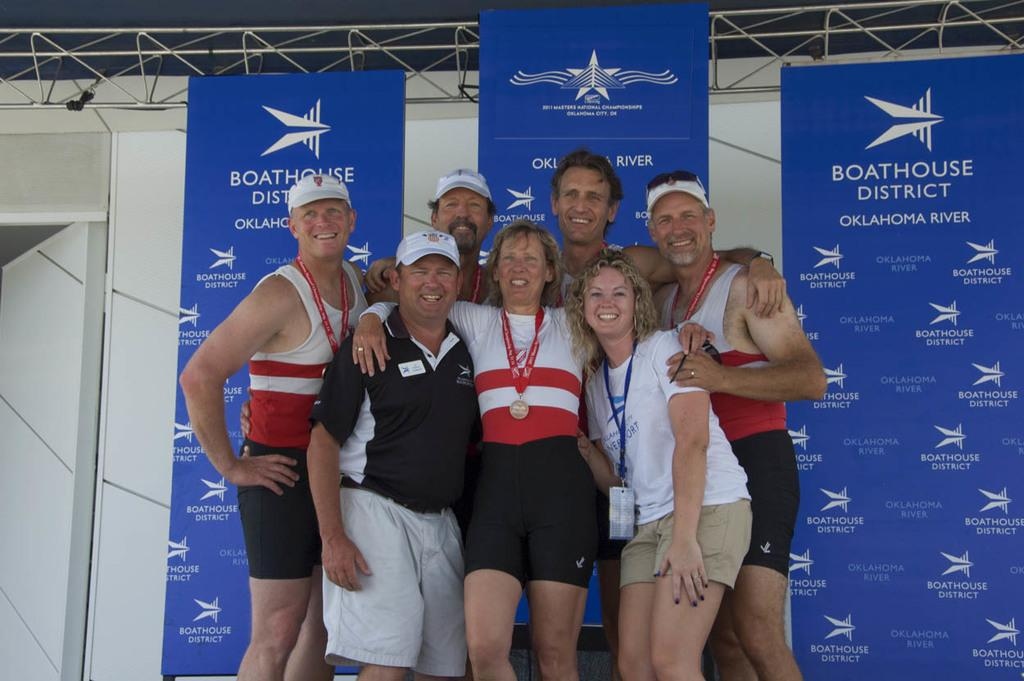Provide a one-sentence caption for the provided image. A group of people posing for a photo in front of a poster for Boathouse District Oklahoma River. 